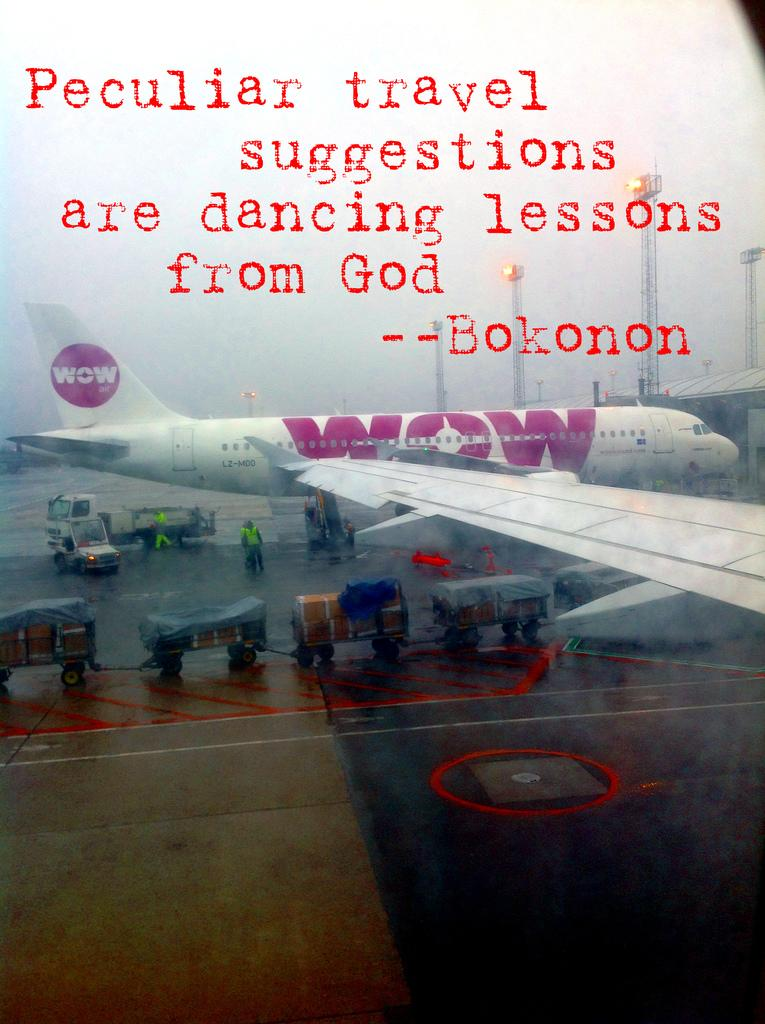<image>
Give a short and clear explanation of the subsequent image. A WOW brand plane is loaded up on the runway below a quote about travel. 